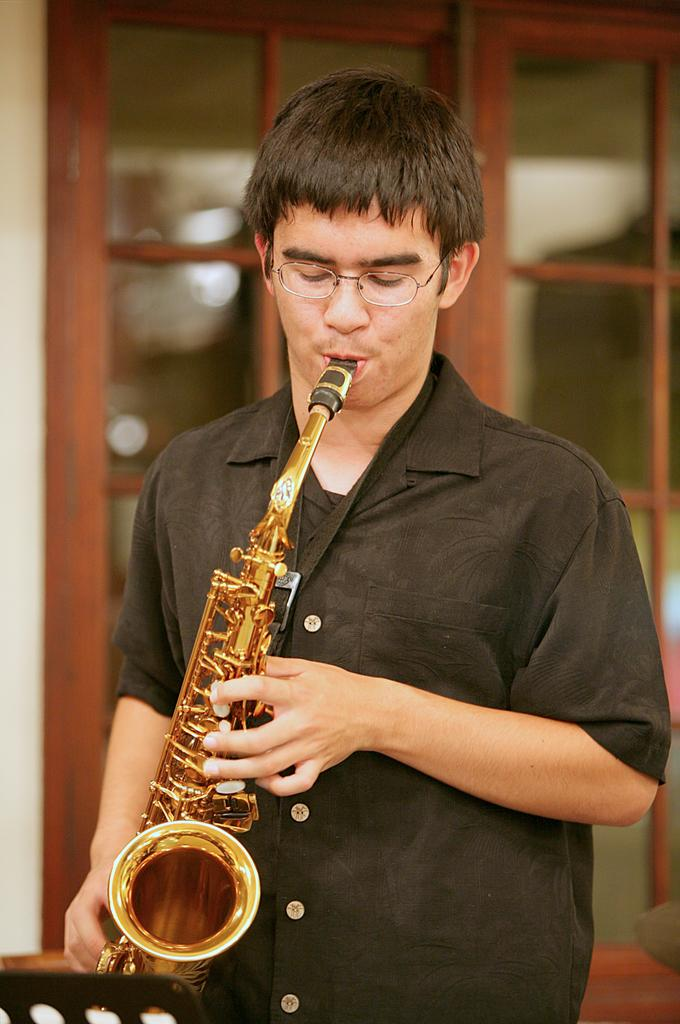What is the main subject in the foreground of the image? There is a man in the foreground of the image. What is the man wearing? The man is wearing a black shirt. What is the man doing in the image? The man is playing a trumpet. What can be seen on the left bottom of the image? There is a book holder on the left bottom of the image. What is visible in the background of the image? There is a glass door and a wall visible in the background of the image. What shape is the guide used by the man in the image? There is no guide mentioned or visible in the image. 